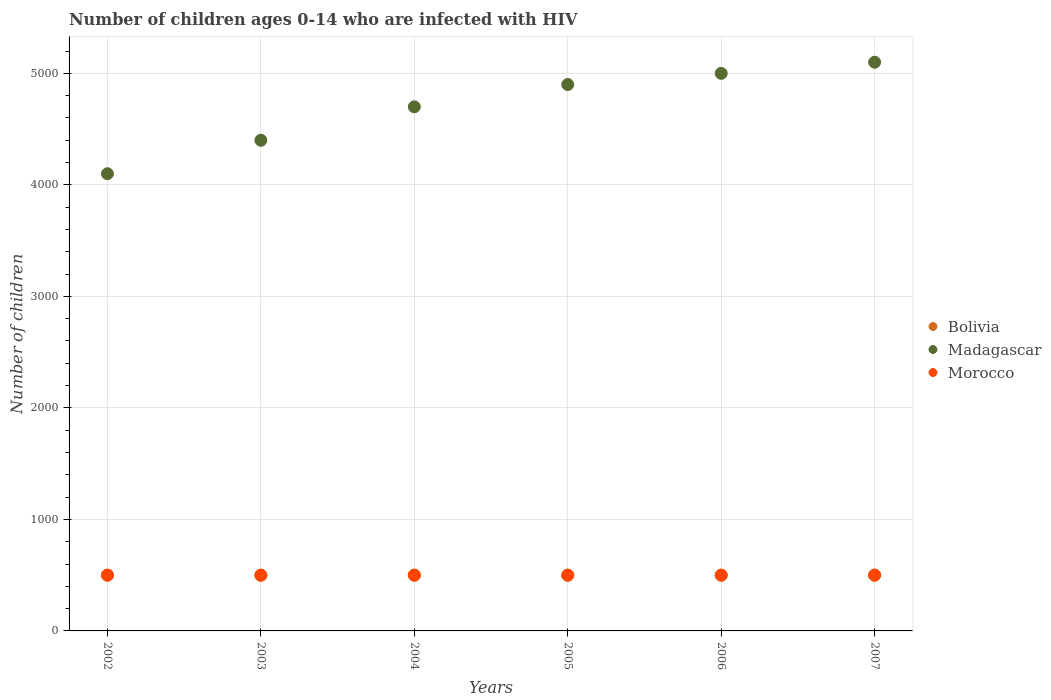Is the number of dotlines equal to the number of legend labels?
Your answer should be compact. Yes. What is the number of HIV infected children in Madagascar in 2006?
Offer a terse response. 5000. Across all years, what is the maximum number of HIV infected children in Morocco?
Your answer should be very brief. 500. Across all years, what is the minimum number of HIV infected children in Morocco?
Your answer should be compact. 500. What is the total number of HIV infected children in Bolivia in the graph?
Provide a succinct answer. 3000. What is the difference between the number of HIV infected children in Madagascar in 2003 and that in 2006?
Make the answer very short. -600. What is the difference between the number of HIV infected children in Morocco in 2006 and the number of HIV infected children in Bolivia in 2004?
Ensure brevity in your answer.  0. In the year 2007, what is the difference between the number of HIV infected children in Morocco and number of HIV infected children in Madagascar?
Your answer should be compact. -4600. In how many years, is the number of HIV infected children in Bolivia greater than 4600?
Provide a short and direct response. 0. Is the difference between the number of HIV infected children in Morocco in 2004 and 2006 greater than the difference between the number of HIV infected children in Madagascar in 2004 and 2006?
Your answer should be very brief. Yes. What is the difference between the highest and the second highest number of HIV infected children in Bolivia?
Your response must be concise. 0. In how many years, is the number of HIV infected children in Madagascar greater than the average number of HIV infected children in Madagascar taken over all years?
Make the answer very short. 3. Is the sum of the number of HIV infected children in Morocco in 2006 and 2007 greater than the maximum number of HIV infected children in Madagascar across all years?
Provide a short and direct response. No. Does the number of HIV infected children in Bolivia monotonically increase over the years?
Your answer should be compact. No. Are the values on the major ticks of Y-axis written in scientific E-notation?
Offer a very short reply. No. Does the graph contain any zero values?
Offer a very short reply. No. Where does the legend appear in the graph?
Your answer should be very brief. Center right. How are the legend labels stacked?
Make the answer very short. Vertical. What is the title of the graph?
Offer a very short reply. Number of children ages 0-14 who are infected with HIV. What is the label or title of the X-axis?
Ensure brevity in your answer.  Years. What is the label or title of the Y-axis?
Offer a very short reply. Number of children. What is the Number of children of Bolivia in 2002?
Your answer should be very brief. 500. What is the Number of children in Madagascar in 2002?
Your response must be concise. 4100. What is the Number of children of Madagascar in 2003?
Provide a short and direct response. 4400. What is the Number of children of Bolivia in 2004?
Offer a terse response. 500. What is the Number of children in Madagascar in 2004?
Your answer should be very brief. 4700. What is the Number of children of Morocco in 2004?
Your answer should be compact. 500. What is the Number of children of Madagascar in 2005?
Your answer should be compact. 4900. What is the Number of children of Bolivia in 2006?
Provide a short and direct response. 500. What is the Number of children in Madagascar in 2006?
Offer a very short reply. 5000. What is the Number of children in Bolivia in 2007?
Offer a terse response. 500. What is the Number of children of Madagascar in 2007?
Make the answer very short. 5100. What is the Number of children of Morocco in 2007?
Offer a very short reply. 500. Across all years, what is the maximum Number of children of Bolivia?
Provide a succinct answer. 500. Across all years, what is the maximum Number of children of Madagascar?
Offer a very short reply. 5100. Across all years, what is the maximum Number of children in Morocco?
Provide a short and direct response. 500. Across all years, what is the minimum Number of children of Madagascar?
Give a very brief answer. 4100. Across all years, what is the minimum Number of children in Morocco?
Ensure brevity in your answer.  500. What is the total Number of children of Bolivia in the graph?
Provide a short and direct response. 3000. What is the total Number of children of Madagascar in the graph?
Ensure brevity in your answer.  2.82e+04. What is the total Number of children in Morocco in the graph?
Your answer should be compact. 3000. What is the difference between the Number of children of Madagascar in 2002 and that in 2003?
Give a very brief answer. -300. What is the difference between the Number of children in Morocco in 2002 and that in 2003?
Ensure brevity in your answer.  0. What is the difference between the Number of children in Bolivia in 2002 and that in 2004?
Ensure brevity in your answer.  0. What is the difference between the Number of children of Madagascar in 2002 and that in 2004?
Your answer should be very brief. -600. What is the difference between the Number of children in Madagascar in 2002 and that in 2005?
Give a very brief answer. -800. What is the difference between the Number of children of Bolivia in 2002 and that in 2006?
Make the answer very short. 0. What is the difference between the Number of children of Madagascar in 2002 and that in 2006?
Your answer should be compact. -900. What is the difference between the Number of children in Bolivia in 2002 and that in 2007?
Make the answer very short. 0. What is the difference between the Number of children in Madagascar in 2002 and that in 2007?
Provide a short and direct response. -1000. What is the difference between the Number of children in Bolivia in 2003 and that in 2004?
Offer a terse response. 0. What is the difference between the Number of children in Madagascar in 2003 and that in 2004?
Make the answer very short. -300. What is the difference between the Number of children in Morocco in 2003 and that in 2004?
Your answer should be compact. 0. What is the difference between the Number of children of Bolivia in 2003 and that in 2005?
Your answer should be compact. 0. What is the difference between the Number of children in Madagascar in 2003 and that in 2005?
Ensure brevity in your answer.  -500. What is the difference between the Number of children of Morocco in 2003 and that in 2005?
Your answer should be compact. 0. What is the difference between the Number of children in Bolivia in 2003 and that in 2006?
Provide a short and direct response. 0. What is the difference between the Number of children in Madagascar in 2003 and that in 2006?
Your answer should be very brief. -600. What is the difference between the Number of children in Bolivia in 2003 and that in 2007?
Offer a very short reply. 0. What is the difference between the Number of children in Madagascar in 2003 and that in 2007?
Offer a terse response. -700. What is the difference between the Number of children in Morocco in 2003 and that in 2007?
Provide a succinct answer. 0. What is the difference between the Number of children in Madagascar in 2004 and that in 2005?
Keep it short and to the point. -200. What is the difference between the Number of children of Morocco in 2004 and that in 2005?
Give a very brief answer. 0. What is the difference between the Number of children of Madagascar in 2004 and that in 2006?
Offer a terse response. -300. What is the difference between the Number of children in Bolivia in 2004 and that in 2007?
Keep it short and to the point. 0. What is the difference between the Number of children in Madagascar in 2004 and that in 2007?
Your answer should be very brief. -400. What is the difference between the Number of children in Bolivia in 2005 and that in 2006?
Offer a terse response. 0. What is the difference between the Number of children in Madagascar in 2005 and that in 2006?
Your response must be concise. -100. What is the difference between the Number of children in Madagascar in 2005 and that in 2007?
Make the answer very short. -200. What is the difference between the Number of children of Madagascar in 2006 and that in 2007?
Offer a terse response. -100. What is the difference between the Number of children of Bolivia in 2002 and the Number of children of Madagascar in 2003?
Ensure brevity in your answer.  -3900. What is the difference between the Number of children in Madagascar in 2002 and the Number of children in Morocco in 2003?
Give a very brief answer. 3600. What is the difference between the Number of children of Bolivia in 2002 and the Number of children of Madagascar in 2004?
Provide a succinct answer. -4200. What is the difference between the Number of children in Madagascar in 2002 and the Number of children in Morocco in 2004?
Your response must be concise. 3600. What is the difference between the Number of children in Bolivia in 2002 and the Number of children in Madagascar in 2005?
Keep it short and to the point. -4400. What is the difference between the Number of children in Bolivia in 2002 and the Number of children in Morocco in 2005?
Offer a terse response. 0. What is the difference between the Number of children of Madagascar in 2002 and the Number of children of Morocco in 2005?
Keep it short and to the point. 3600. What is the difference between the Number of children of Bolivia in 2002 and the Number of children of Madagascar in 2006?
Your response must be concise. -4500. What is the difference between the Number of children of Madagascar in 2002 and the Number of children of Morocco in 2006?
Keep it short and to the point. 3600. What is the difference between the Number of children of Bolivia in 2002 and the Number of children of Madagascar in 2007?
Provide a short and direct response. -4600. What is the difference between the Number of children of Bolivia in 2002 and the Number of children of Morocco in 2007?
Provide a succinct answer. 0. What is the difference between the Number of children of Madagascar in 2002 and the Number of children of Morocco in 2007?
Your response must be concise. 3600. What is the difference between the Number of children in Bolivia in 2003 and the Number of children in Madagascar in 2004?
Keep it short and to the point. -4200. What is the difference between the Number of children in Madagascar in 2003 and the Number of children in Morocco in 2004?
Keep it short and to the point. 3900. What is the difference between the Number of children of Bolivia in 2003 and the Number of children of Madagascar in 2005?
Your answer should be compact. -4400. What is the difference between the Number of children in Madagascar in 2003 and the Number of children in Morocco in 2005?
Keep it short and to the point. 3900. What is the difference between the Number of children of Bolivia in 2003 and the Number of children of Madagascar in 2006?
Provide a succinct answer. -4500. What is the difference between the Number of children in Madagascar in 2003 and the Number of children in Morocco in 2006?
Provide a succinct answer. 3900. What is the difference between the Number of children in Bolivia in 2003 and the Number of children in Madagascar in 2007?
Ensure brevity in your answer.  -4600. What is the difference between the Number of children of Madagascar in 2003 and the Number of children of Morocco in 2007?
Keep it short and to the point. 3900. What is the difference between the Number of children in Bolivia in 2004 and the Number of children in Madagascar in 2005?
Your answer should be compact. -4400. What is the difference between the Number of children of Madagascar in 2004 and the Number of children of Morocco in 2005?
Ensure brevity in your answer.  4200. What is the difference between the Number of children of Bolivia in 2004 and the Number of children of Madagascar in 2006?
Your response must be concise. -4500. What is the difference between the Number of children in Madagascar in 2004 and the Number of children in Morocco in 2006?
Provide a succinct answer. 4200. What is the difference between the Number of children of Bolivia in 2004 and the Number of children of Madagascar in 2007?
Ensure brevity in your answer.  -4600. What is the difference between the Number of children in Bolivia in 2004 and the Number of children in Morocco in 2007?
Your answer should be very brief. 0. What is the difference between the Number of children in Madagascar in 2004 and the Number of children in Morocco in 2007?
Provide a succinct answer. 4200. What is the difference between the Number of children in Bolivia in 2005 and the Number of children in Madagascar in 2006?
Give a very brief answer. -4500. What is the difference between the Number of children in Bolivia in 2005 and the Number of children in Morocco in 2006?
Give a very brief answer. 0. What is the difference between the Number of children in Madagascar in 2005 and the Number of children in Morocco in 2006?
Offer a very short reply. 4400. What is the difference between the Number of children in Bolivia in 2005 and the Number of children in Madagascar in 2007?
Offer a terse response. -4600. What is the difference between the Number of children of Madagascar in 2005 and the Number of children of Morocco in 2007?
Provide a succinct answer. 4400. What is the difference between the Number of children in Bolivia in 2006 and the Number of children in Madagascar in 2007?
Give a very brief answer. -4600. What is the difference between the Number of children in Bolivia in 2006 and the Number of children in Morocco in 2007?
Your answer should be compact. 0. What is the difference between the Number of children in Madagascar in 2006 and the Number of children in Morocco in 2007?
Keep it short and to the point. 4500. What is the average Number of children in Bolivia per year?
Provide a short and direct response. 500. What is the average Number of children of Madagascar per year?
Provide a succinct answer. 4700. What is the average Number of children of Morocco per year?
Your response must be concise. 500. In the year 2002, what is the difference between the Number of children of Bolivia and Number of children of Madagascar?
Provide a short and direct response. -3600. In the year 2002, what is the difference between the Number of children in Madagascar and Number of children in Morocco?
Your answer should be compact. 3600. In the year 2003, what is the difference between the Number of children of Bolivia and Number of children of Madagascar?
Ensure brevity in your answer.  -3900. In the year 2003, what is the difference between the Number of children of Bolivia and Number of children of Morocco?
Make the answer very short. 0. In the year 2003, what is the difference between the Number of children of Madagascar and Number of children of Morocco?
Provide a succinct answer. 3900. In the year 2004, what is the difference between the Number of children in Bolivia and Number of children in Madagascar?
Make the answer very short. -4200. In the year 2004, what is the difference between the Number of children of Bolivia and Number of children of Morocco?
Keep it short and to the point. 0. In the year 2004, what is the difference between the Number of children of Madagascar and Number of children of Morocco?
Offer a very short reply. 4200. In the year 2005, what is the difference between the Number of children of Bolivia and Number of children of Madagascar?
Make the answer very short. -4400. In the year 2005, what is the difference between the Number of children of Madagascar and Number of children of Morocco?
Ensure brevity in your answer.  4400. In the year 2006, what is the difference between the Number of children of Bolivia and Number of children of Madagascar?
Your answer should be very brief. -4500. In the year 2006, what is the difference between the Number of children of Bolivia and Number of children of Morocco?
Keep it short and to the point. 0. In the year 2006, what is the difference between the Number of children of Madagascar and Number of children of Morocco?
Your answer should be compact. 4500. In the year 2007, what is the difference between the Number of children in Bolivia and Number of children in Madagascar?
Give a very brief answer. -4600. In the year 2007, what is the difference between the Number of children of Madagascar and Number of children of Morocco?
Make the answer very short. 4600. What is the ratio of the Number of children of Madagascar in 2002 to that in 2003?
Make the answer very short. 0.93. What is the ratio of the Number of children of Morocco in 2002 to that in 2003?
Your answer should be very brief. 1. What is the ratio of the Number of children of Bolivia in 2002 to that in 2004?
Offer a terse response. 1. What is the ratio of the Number of children in Madagascar in 2002 to that in 2004?
Make the answer very short. 0.87. What is the ratio of the Number of children of Morocco in 2002 to that in 2004?
Keep it short and to the point. 1. What is the ratio of the Number of children of Madagascar in 2002 to that in 2005?
Give a very brief answer. 0.84. What is the ratio of the Number of children of Bolivia in 2002 to that in 2006?
Ensure brevity in your answer.  1. What is the ratio of the Number of children in Madagascar in 2002 to that in 2006?
Give a very brief answer. 0.82. What is the ratio of the Number of children in Madagascar in 2002 to that in 2007?
Your answer should be very brief. 0.8. What is the ratio of the Number of children of Morocco in 2002 to that in 2007?
Your response must be concise. 1. What is the ratio of the Number of children in Bolivia in 2003 to that in 2004?
Offer a terse response. 1. What is the ratio of the Number of children in Madagascar in 2003 to that in 2004?
Offer a terse response. 0.94. What is the ratio of the Number of children of Morocco in 2003 to that in 2004?
Ensure brevity in your answer.  1. What is the ratio of the Number of children of Bolivia in 2003 to that in 2005?
Your answer should be very brief. 1. What is the ratio of the Number of children of Madagascar in 2003 to that in 2005?
Give a very brief answer. 0.9. What is the ratio of the Number of children of Bolivia in 2003 to that in 2006?
Make the answer very short. 1. What is the ratio of the Number of children of Bolivia in 2003 to that in 2007?
Your answer should be very brief. 1. What is the ratio of the Number of children of Madagascar in 2003 to that in 2007?
Provide a short and direct response. 0.86. What is the ratio of the Number of children in Bolivia in 2004 to that in 2005?
Give a very brief answer. 1. What is the ratio of the Number of children in Madagascar in 2004 to that in 2005?
Provide a short and direct response. 0.96. What is the ratio of the Number of children in Madagascar in 2004 to that in 2006?
Provide a succinct answer. 0.94. What is the ratio of the Number of children of Bolivia in 2004 to that in 2007?
Give a very brief answer. 1. What is the ratio of the Number of children of Madagascar in 2004 to that in 2007?
Make the answer very short. 0.92. What is the ratio of the Number of children of Madagascar in 2005 to that in 2006?
Give a very brief answer. 0.98. What is the ratio of the Number of children in Madagascar in 2005 to that in 2007?
Keep it short and to the point. 0.96. What is the ratio of the Number of children in Bolivia in 2006 to that in 2007?
Ensure brevity in your answer.  1. What is the ratio of the Number of children of Madagascar in 2006 to that in 2007?
Offer a very short reply. 0.98. What is the ratio of the Number of children in Morocco in 2006 to that in 2007?
Provide a short and direct response. 1. What is the difference between the highest and the second highest Number of children in Bolivia?
Make the answer very short. 0. What is the difference between the highest and the second highest Number of children in Madagascar?
Your answer should be compact. 100. 